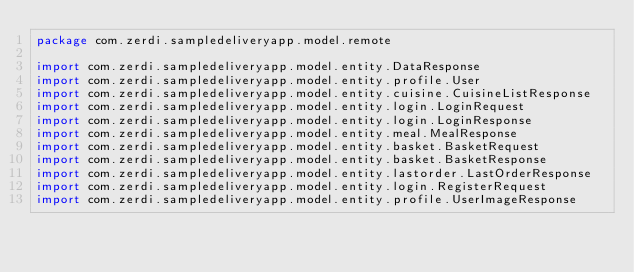Convert code to text. <code><loc_0><loc_0><loc_500><loc_500><_Kotlin_>package com.zerdi.sampledeliveryapp.model.remote

import com.zerdi.sampledeliveryapp.model.entity.DataResponse
import com.zerdi.sampledeliveryapp.model.entity.profile.User
import com.zerdi.sampledeliveryapp.model.entity.cuisine.CuisineListResponse
import com.zerdi.sampledeliveryapp.model.entity.login.LoginRequest
import com.zerdi.sampledeliveryapp.model.entity.login.LoginResponse
import com.zerdi.sampledeliveryapp.model.entity.meal.MealResponse
import com.zerdi.sampledeliveryapp.model.entity.basket.BasketRequest
import com.zerdi.sampledeliveryapp.model.entity.basket.BasketResponse
import com.zerdi.sampledeliveryapp.model.entity.lastorder.LastOrderResponse
import com.zerdi.sampledeliveryapp.model.entity.login.RegisterRequest
import com.zerdi.sampledeliveryapp.model.entity.profile.UserImageResponse</code> 